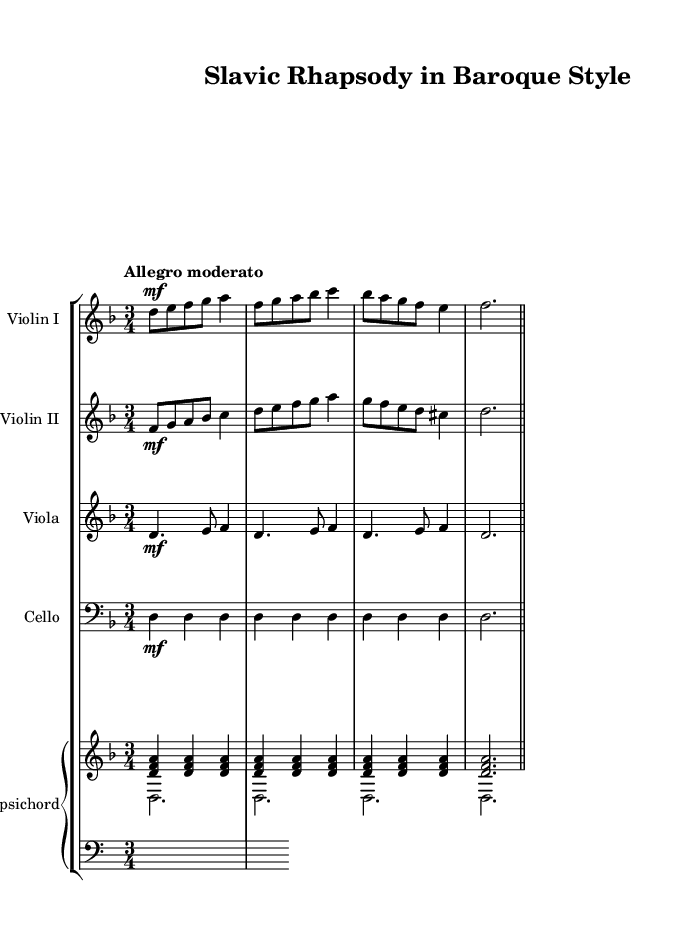What is the key signature of this music? The key signature is indicated at the beginning of the staff, which shows two flats, corresponding to the key of D minor.
Answer: D minor What is the time signature of this music? The time signature is shown at the beginning of the upper staff, indicated by 3/4, meaning there are three beats per measure and a quarter note gets one beat.
Answer: 3/4 What tempo marking is indicated in the piece? The tempo marking, located at the beginning of the score, states "Allegro moderato," which indicates a moderately fast tempo.
Answer: Allegro moderato How many measures are in the "Violin I" part? Counting the measures represented in the "Violin I" part, there are a total of 6 measures before reaching the repeat bar.
Answer: 6 Which instruments are included in this chamber music piece? By examining the score, the instruments listed consist of two violins, a viola, a cello, and a harpsichord.
Answer: Violin I, Violin II, Viola, Cello, Harpsichord What is the dynamic marking used in the first violin part? The first violin part begins with the dynamic marking "mf," which indicates a moderately loud volume.
Answer: mf What is the role of the harpsichord in this piece? The harpsichord serves both as a harmonic accompaniment and a support for the melodic lines provided by other instruments.
Answer: Harmonic accompaniment 